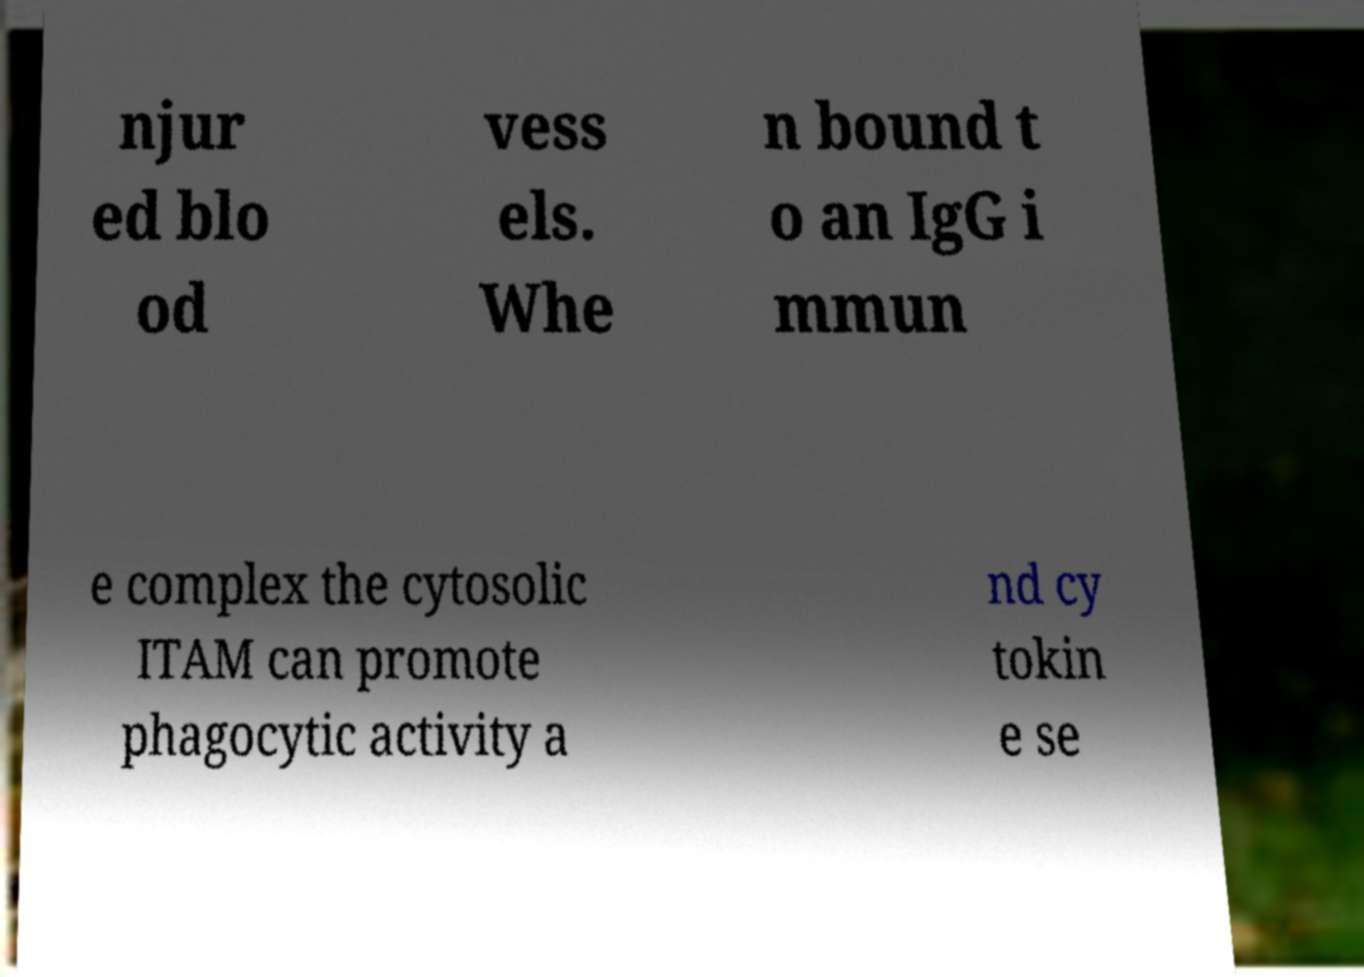Could you extract and type out the text from this image? njur ed blo od vess els. Whe n bound t o an IgG i mmun e complex the cytosolic ITAM can promote phagocytic activity a nd cy tokin e se 